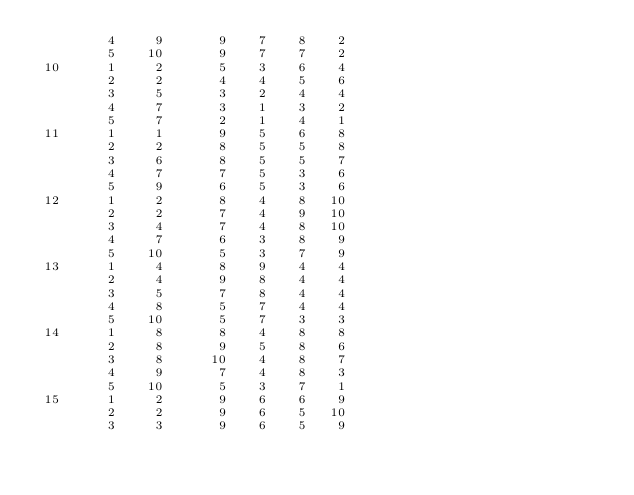<code> <loc_0><loc_0><loc_500><loc_500><_ObjectiveC_>         4     9       9    7    8    2
         5    10       9    7    7    2
 10      1     2       5    3    6    4
         2     2       4    4    5    6
         3     5       3    2    4    4
         4     7       3    1    3    2
         5     7       2    1    4    1
 11      1     1       9    5    6    8
         2     2       8    5    5    8
         3     6       8    5    5    7
         4     7       7    5    3    6
         5     9       6    5    3    6
 12      1     2       8    4    8   10
         2     2       7    4    9   10
         3     4       7    4    8   10
         4     7       6    3    8    9
         5    10       5    3    7    9
 13      1     4       8    9    4    4
         2     4       9    8    4    4
         3     5       7    8    4    4
         4     8       5    7    4    4
         5    10       5    7    3    3
 14      1     8       8    4    8    8
         2     8       9    5    8    6
         3     8      10    4    8    7
         4     9       7    4    8    3
         5    10       5    3    7    1
 15      1     2       9    6    6    9
         2     2       9    6    5   10
         3     3       9    6    5    9</code> 